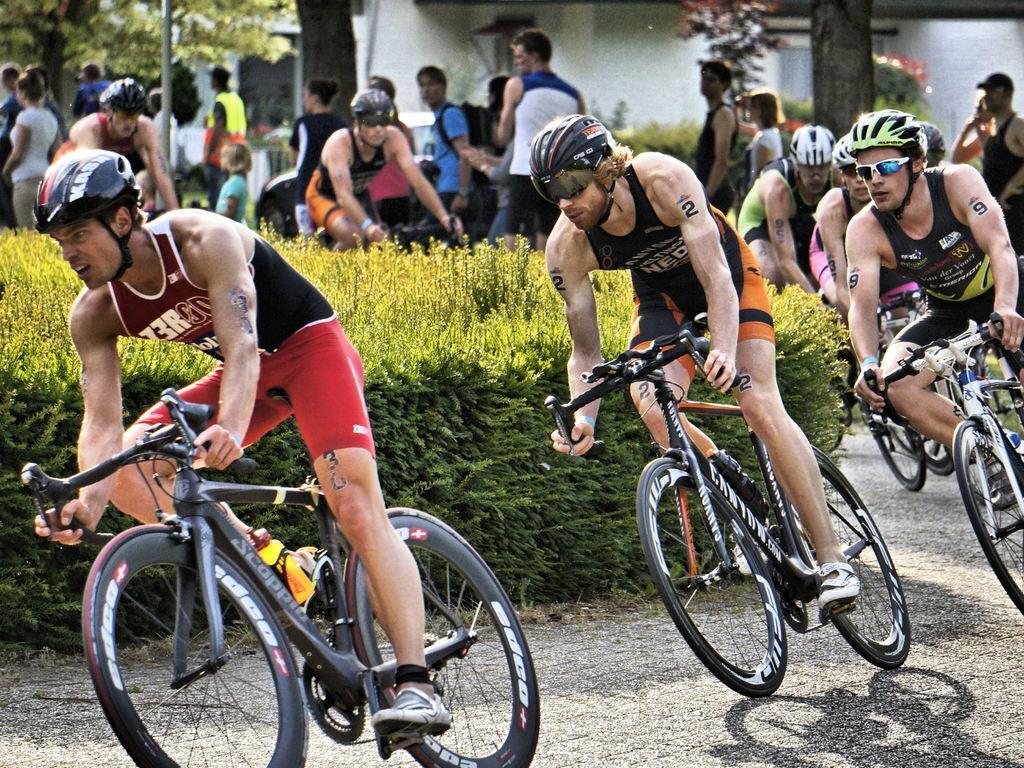Describe this image in one or two sentences. In this picture there are many people riding a bicycle on the road and in the background and many people standing, on to their left there are some plants, buildings and their some trees, poles. 